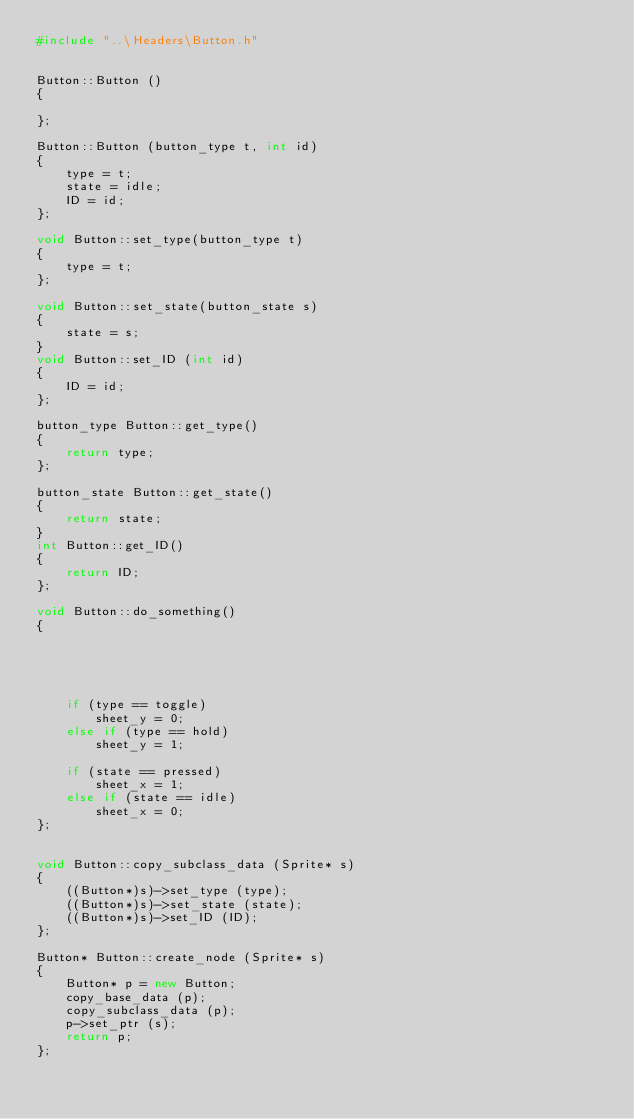Convert code to text. <code><loc_0><loc_0><loc_500><loc_500><_C++_>#include "..\Headers\Button.h"


Button::Button ()
{

};

Button::Button (button_type t, int id)
{
	type = t;
	state = idle;
	ID = id;
};

void Button::set_type(button_type t)
{
	type = t;
};

void Button::set_state(button_state s)
{
	state = s;
}
void Button::set_ID (int id)
{
	ID = id;
};

button_type Button::get_type()
{
	return type;
};

button_state Button::get_state()
{
	return state;
}
int Button::get_ID()
{
	return ID;
};

void Button::do_something()
{





	if (type == toggle)
		sheet_y = 0;
	else if (type == hold)
		sheet_y = 1;

	if (state == pressed)
		sheet_x = 1;
	else if (state == idle)
		sheet_x = 0;
};


void Button::copy_subclass_data (Sprite* s)
{
	((Button*)s)->set_type (type);
	((Button*)s)->set_state (state);
	((Button*)s)->set_ID (ID);
};

Button* Button::create_node (Sprite* s)
{
	Button* p = new Button;
	copy_base_data (p);
	copy_subclass_data (p);
	p->set_ptr (s);
	return p;
};</code> 